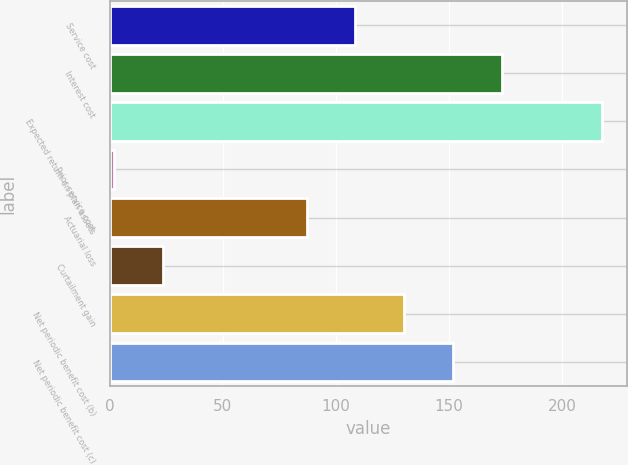<chart> <loc_0><loc_0><loc_500><loc_500><bar_chart><fcel>Service cost<fcel>Interest cost<fcel>Expected return on plan assets<fcel>Prior service cost<fcel>Actuarial loss<fcel>Curtailment gain<fcel>Net periodic benefit cost (b)<fcel>Net periodic benefit cost (c)<nl><fcel>108.6<fcel>173.4<fcel>218<fcel>2<fcel>87<fcel>23.6<fcel>130.2<fcel>151.8<nl></chart> 